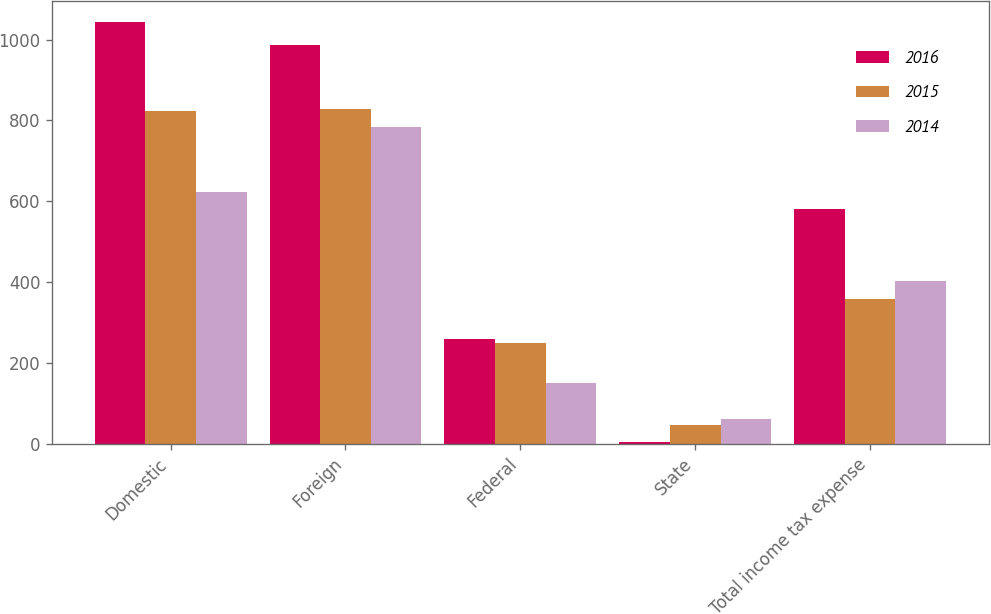Convert chart. <chart><loc_0><loc_0><loc_500><loc_500><stacked_bar_chart><ecel><fcel>Domestic<fcel>Foreign<fcel>Federal<fcel>State<fcel>Total income tax expense<nl><fcel>2016<fcel>1043<fcel>986<fcel>258<fcel>5<fcel>580<nl><fcel>2015<fcel>824<fcel>829<fcel>250<fcel>46<fcel>358<nl><fcel>2014<fcel>623<fcel>784<fcel>151<fcel>61<fcel>402<nl></chart> 